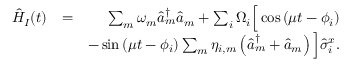Convert formula to latex. <formula><loc_0><loc_0><loc_500><loc_500>\begin{array} { r l r } { \hat { H } _ { I } ( t ) } & { = } & { \sum _ { m } \omega _ { m } \hat { a } _ { m } ^ { \dag } \hat { a } _ { m } + \sum _ { i } \Omega _ { i } \left [ \cos \left ( \mu t - \phi _ { i } \right ) } \\ & { - \sin \left ( \mu t - \phi _ { i } \right ) \sum _ { m } \eta _ { i , m } \left ( \hat { a } _ { m } ^ { \dag } + \hat { a } _ { m } \right ) \right ] \hat { \sigma } _ { i } ^ { x } . } \end{array}</formula> 